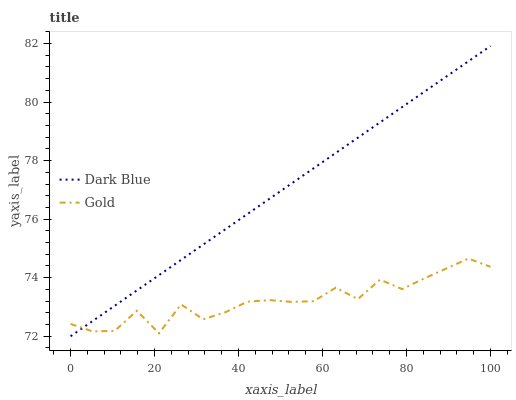Does Gold have the minimum area under the curve?
Answer yes or no. Yes. Does Dark Blue have the maximum area under the curve?
Answer yes or no. Yes. Does Gold have the maximum area under the curve?
Answer yes or no. No. Is Dark Blue the smoothest?
Answer yes or no. Yes. Is Gold the roughest?
Answer yes or no. Yes. Is Gold the smoothest?
Answer yes or no. No. Does Dark Blue have the lowest value?
Answer yes or no. Yes. Does Gold have the lowest value?
Answer yes or no. No. Does Dark Blue have the highest value?
Answer yes or no. Yes. Does Gold have the highest value?
Answer yes or no. No. Does Gold intersect Dark Blue?
Answer yes or no. Yes. Is Gold less than Dark Blue?
Answer yes or no. No. Is Gold greater than Dark Blue?
Answer yes or no. No. 